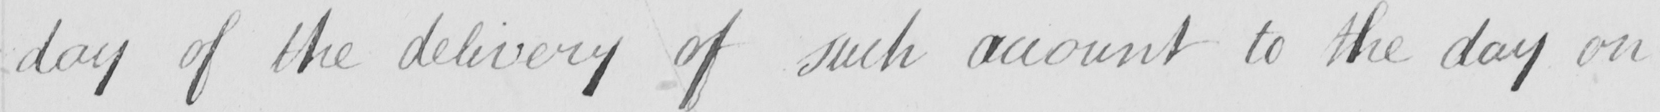Please provide the text content of this handwritten line. day of the delivery of such account to the day on 